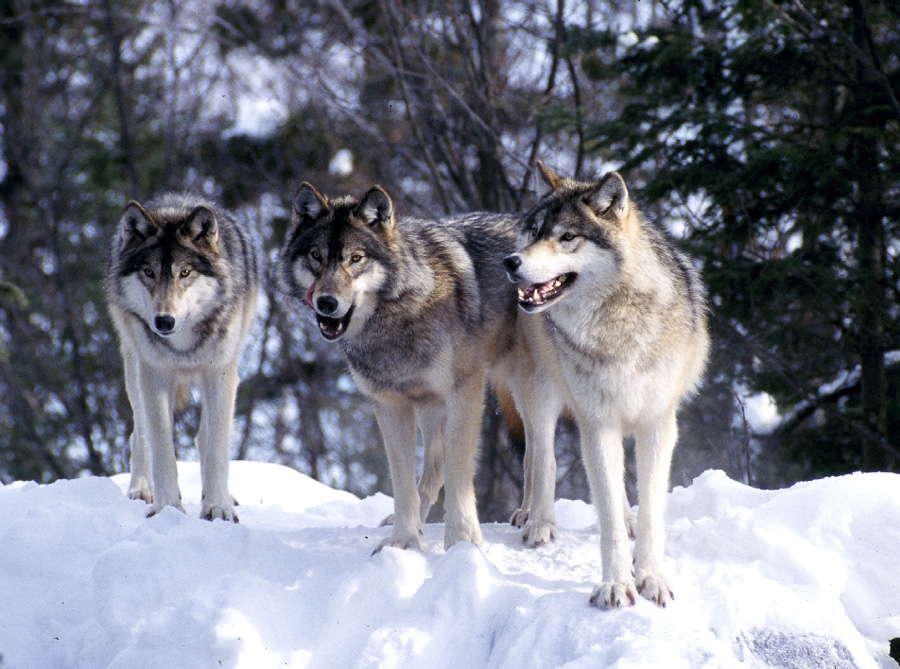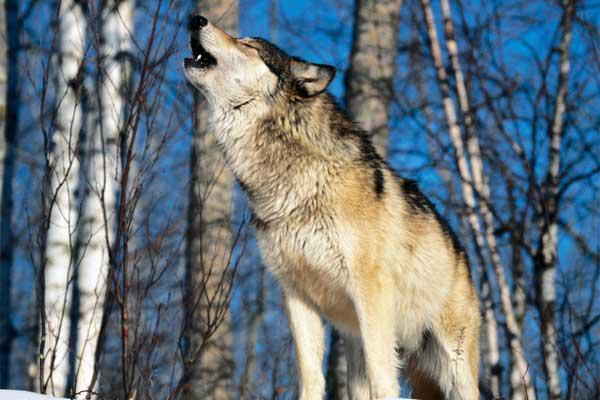The first image is the image on the left, the second image is the image on the right. Given the left and right images, does the statement "At least one wolf is standing in front of trees with its head raised in a howling pose." hold true? Answer yes or no. Yes. 